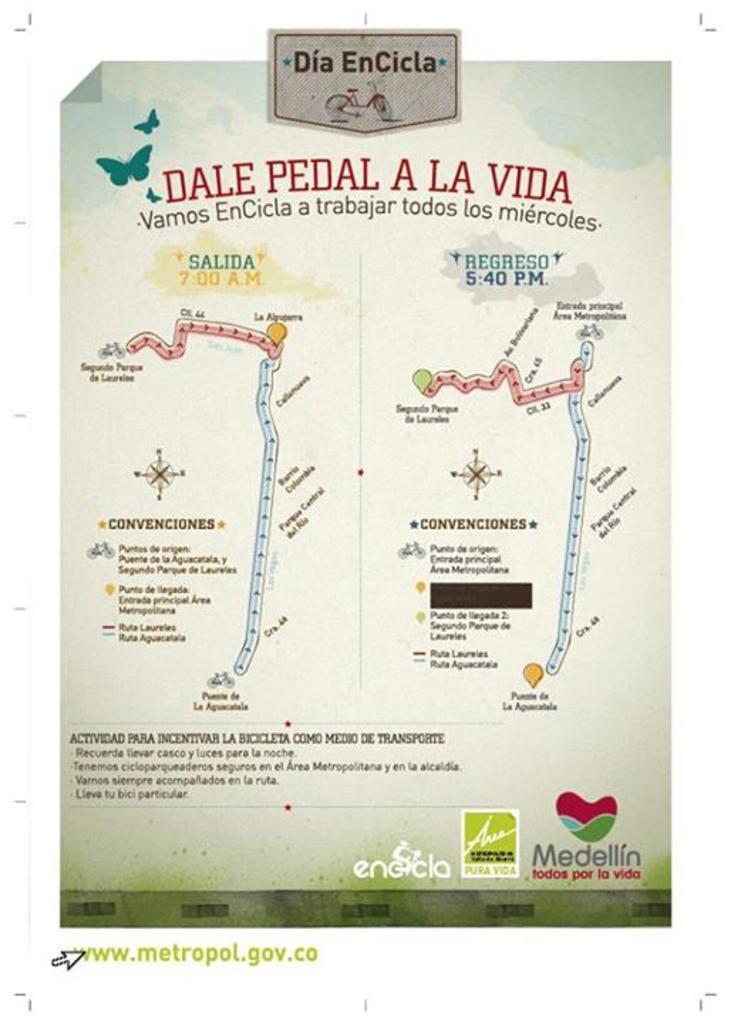What is the title to the event map?
Make the answer very short. Dale pedal a la vida. What is the website in the bottom left?
Give a very brief answer. Www.metropol.gov.co. 